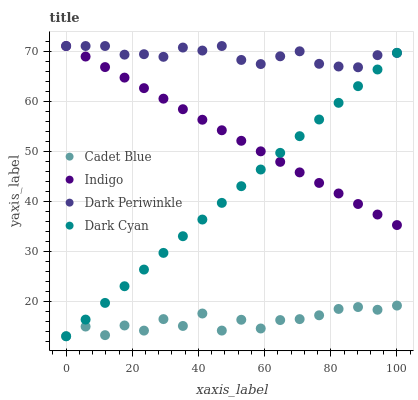Does Cadet Blue have the minimum area under the curve?
Answer yes or no. Yes. Does Dark Periwinkle have the maximum area under the curve?
Answer yes or no. Yes. Does Indigo have the minimum area under the curve?
Answer yes or no. No. Does Indigo have the maximum area under the curve?
Answer yes or no. No. Is Dark Cyan the smoothest?
Answer yes or no. Yes. Is Cadet Blue the roughest?
Answer yes or no. Yes. Is Indigo the smoothest?
Answer yes or no. No. Is Indigo the roughest?
Answer yes or no. No. Does Dark Cyan have the lowest value?
Answer yes or no. Yes. Does Indigo have the lowest value?
Answer yes or no. No. Does Dark Periwinkle have the highest value?
Answer yes or no. Yes. Does Cadet Blue have the highest value?
Answer yes or no. No. Is Cadet Blue less than Indigo?
Answer yes or no. Yes. Is Dark Periwinkle greater than Cadet Blue?
Answer yes or no. Yes. Does Dark Periwinkle intersect Dark Cyan?
Answer yes or no. Yes. Is Dark Periwinkle less than Dark Cyan?
Answer yes or no. No. Is Dark Periwinkle greater than Dark Cyan?
Answer yes or no. No. Does Cadet Blue intersect Indigo?
Answer yes or no. No. 